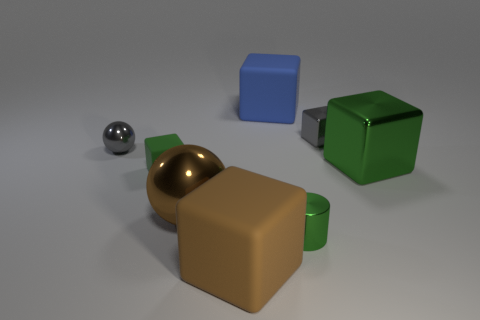Are there any blue blocks that have the same size as the green cylinder?
Your answer should be very brief. No. There is a small rubber block; does it have the same color as the big shiny thing to the right of the cylinder?
Offer a very short reply. Yes. What is the material of the large brown ball?
Provide a succinct answer. Metal. There is a big object on the left side of the brown block; what color is it?
Your answer should be compact. Brown. What number of metallic blocks are the same color as the small metal cylinder?
Ensure brevity in your answer.  1. How many things are both right of the green rubber cube and to the left of the big green cube?
Ensure brevity in your answer.  5. What is the shape of the gray metallic object that is the same size as the gray metallic sphere?
Your answer should be very brief. Cube. How big is the green metal cube?
Your answer should be compact. Large. What material is the small cube that is behind the green block that is left of the large metal object on the right side of the green metal cylinder made of?
Give a very brief answer. Metal. There is another big cube that is made of the same material as the brown block; what is its color?
Your answer should be very brief. Blue. 